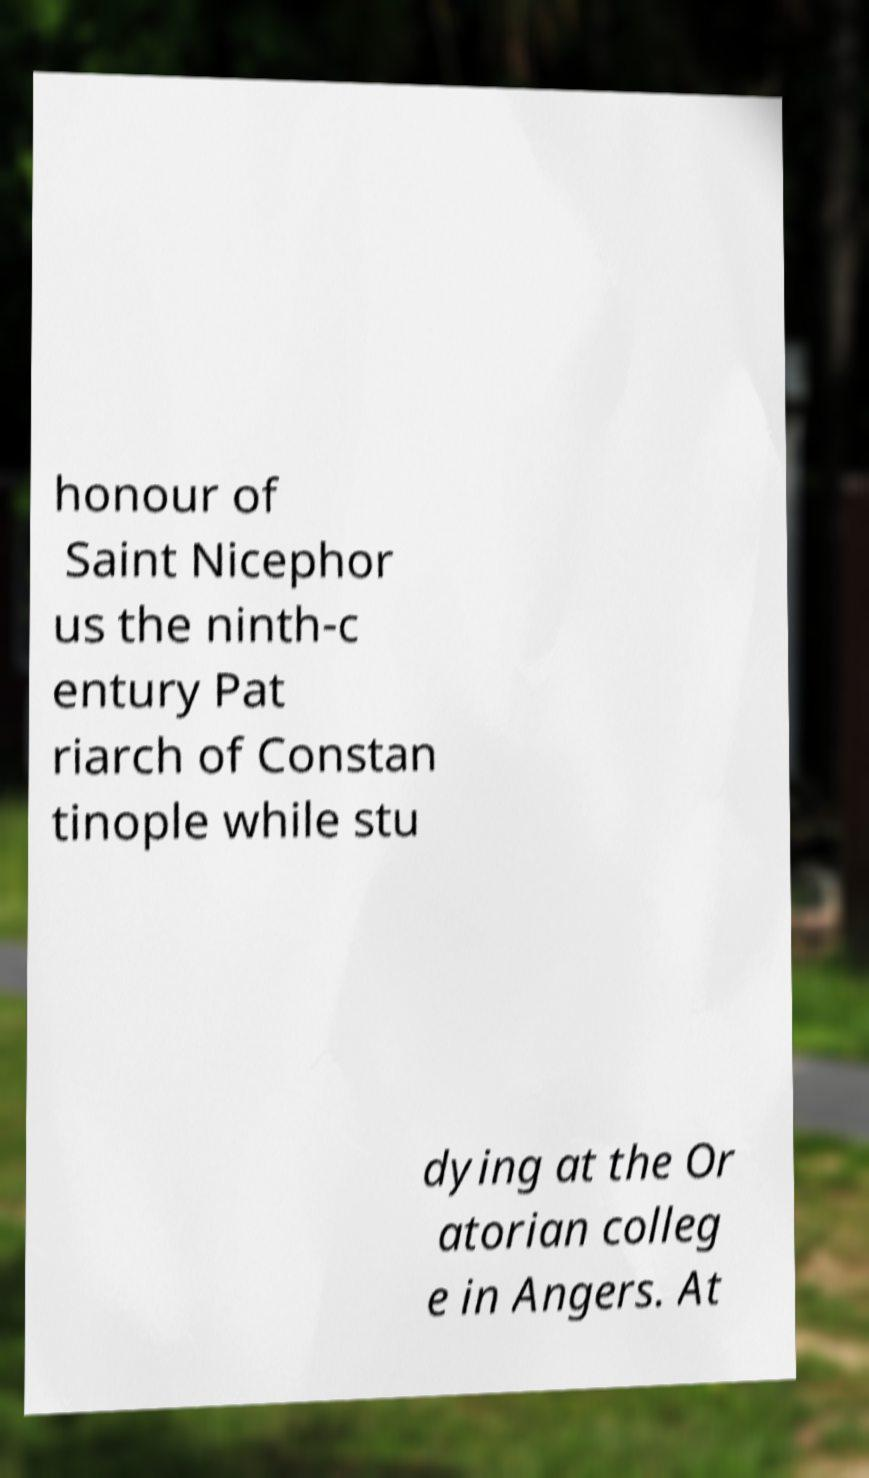Please identify and transcribe the text found in this image. honour of Saint Nicephor us the ninth-c entury Pat riarch of Constan tinople while stu dying at the Or atorian colleg e in Angers. At 